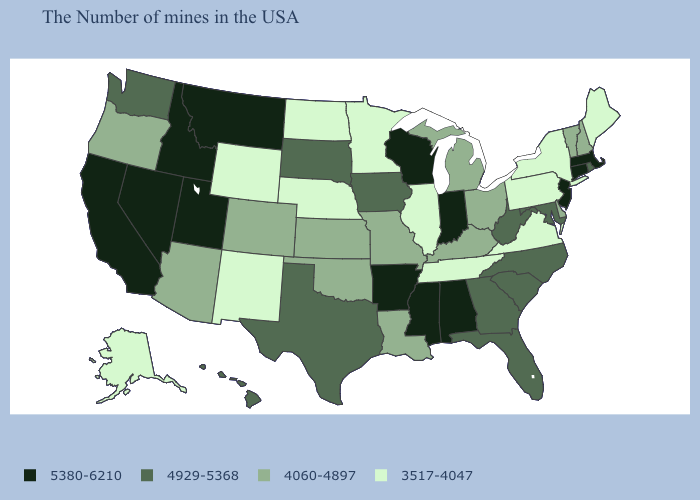What is the value of Minnesota?
Short answer required. 3517-4047. Does Illinois have the same value as North Carolina?
Short answer required. No. Which states have the highest value in the USA?
Give a very brief answer. Massachusetts, Connecticut, New Jersey, Indiana, Alabama, Wisconsin, Mississippi, Arkansas, Utah, Montana, Idaho, Nevada, California. Name the states that have a value in the range 4060-4897?
Be succinct. New Hampshire, Vermont, Delaware, Ohio, Michigan, Kentucky, Louisiana, Missouri, Kansas, Oklahoma, Colorado, Arizona, Oregon. Does the map have missing data?
Concise answer only. No. Does Nevada have the highest value in the USA?
Write a very short answer. Yes. Name the states that have a value in the range 3517-4047?
Keep it brief. Maine, New York, Pennsylvania, Virginia, Tennessee, Illinois, Minnesota, Nebraska, North Dakota, Wyoming, New Mexico, Alaska. Name the states that have a value in the range 3517-4047?
Concise answer only. Maine, New York, Pennsylvania, Virginia, Tennessee, Illinois, Minnesota, Nebraska, North Dakota, Wyoming, New Mexico, Alaska. Which states have the highest value in the USA?
Quick response, please. Massachusetts, Connecticut, New Jersey, Indiana, Alabama, Wisconsin, Mississippi, Arkansas, Utah, Montana, Idaho, Nevada, California. Is the legend a continuous bar?
Give a very brief answer. No. Among the states that border Rhode Island , which have the lowest value?
Give a very brief answer. Massachusetts, Connecticut. Does Idaho have the highest value in the West?
Give a very brief answer. Yes. Name the states that have a value in the range 5380-6210?
Be succinct. Massachusetts, Connecticut, New Jersey, Indiana, Alabama, Wisconsin, Mississippi, Arkansas, Utah, Montana, Idaho, Nevada, California. Does New Hampshire have a higher value than North Dakota?
Quick response, please. Yes. Which states have the lowest value in the USA?
Write a very short answer. Maine, New York, Pennsylvania, Virginia, Tennessee, Illinois, Minnesota, Nebraska, North Dakota, Wyoming, New Mexico, Alaska. 